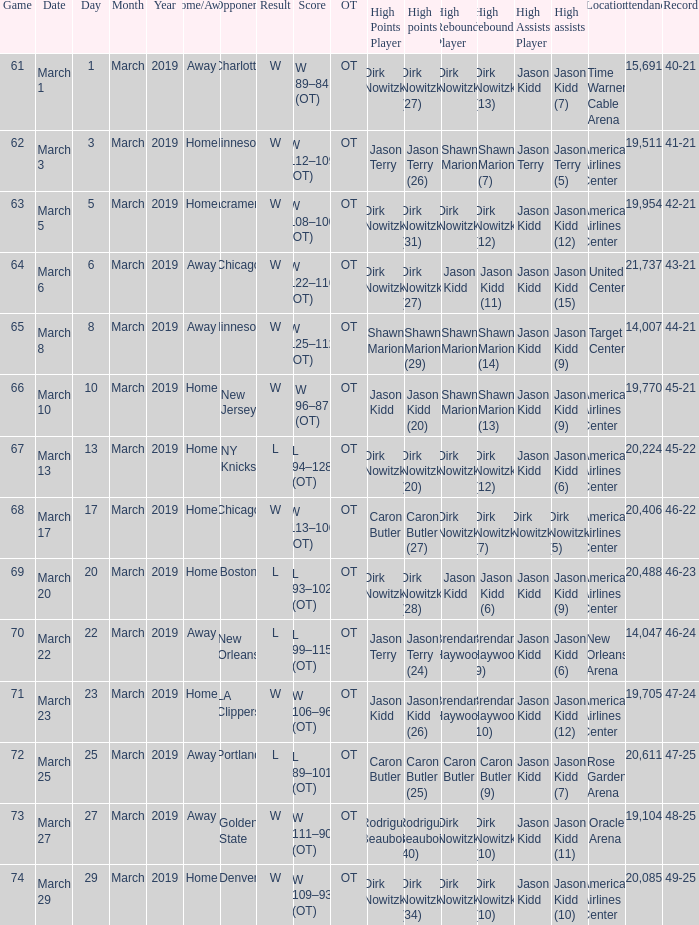How many games had been played when the Mavericks had a 46-22 record? 68.0. 